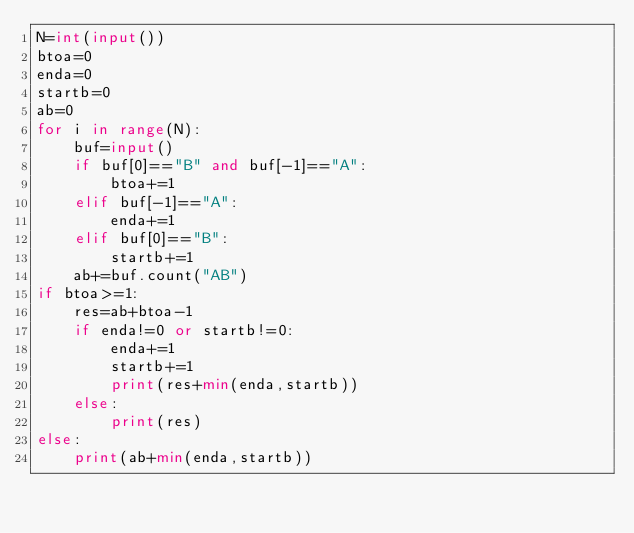Convert code to text. <code><loc_0><loc_0><loc_500><loc_500><_Python_>N=int(input())
btoa=0
enda=0
startb=0
ab=0
for i in range(N):
	buf=input()
	if buf[0]=="B" and buf[-1]=="A":
		btoa+=1
	elif buf[-1]=="A":
		enda+=1
	elif buf[0]=="B":
		startb+=1
	ab+=buf.count("AB")
if btoa>=1:
	res=ab+btoa-1
	if enda!=0 or startb!=0:
		enda+=1
		startb+=1
		print(res+min(enda,startb))
	else:
		print(res)
else:
	print(ab+min(enda,startb))</code> 